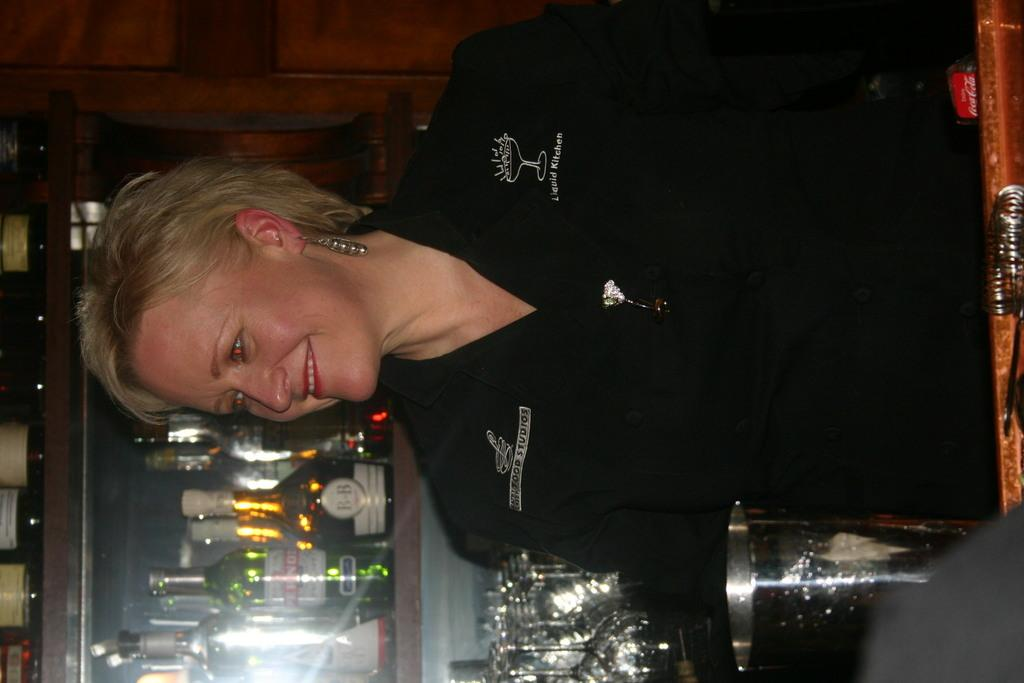What is the main subject of the image? There is a person in the image. What is the person wearing? The person is wearing a black t-shirt. What is the person's facial expression? The person is smiling. What can be seen in the background of the image? There are shelves in the background of the image. What is on the shelves? The shelves are filled with glass bottles. What type of ring is the achiever wearing in the image? There is no achiever or ring present in the image. What is the grandmother doing in the image? There is no grandmother present in the image. 